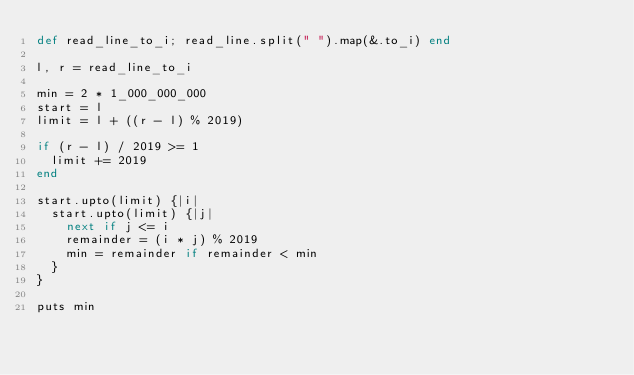<code> <loc_0><loc_0><loc_500><loc_500><_Crystal_>def read_line_to_i; read_line.split(" ").map(&.to_i) end

l, r = read_line_to_i

min = 2 * 1_000_000_000
start = l
limit = l + ((r - l) % 2019)

if (r - l) / 2019 >= 1
  limit += 2019
end

start.upto(limit) {|i|
  start.upto(limit) {|j|
    next if j <= i
    remainder = (i * j) % 2019
    min = remainder if remainder < min
  }
}

puts min
</code> 